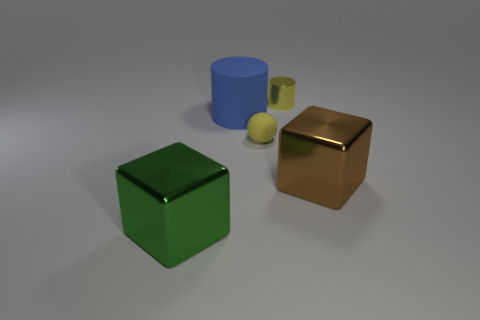Add 5 big rubber cylinders. How many objects exist? 10 Subtract all cubes. How many objects are left? 3 Subtract all small objects. Subtract all big brown rubber cubes. How many objects are left? 3 Add 5 yellow objects. How many yellow objects are left? 7 Add 2 large gray metal things. How many large gray metal things exist? 2 Subtract 1 yellow cylinders. How many objects are left? 4 